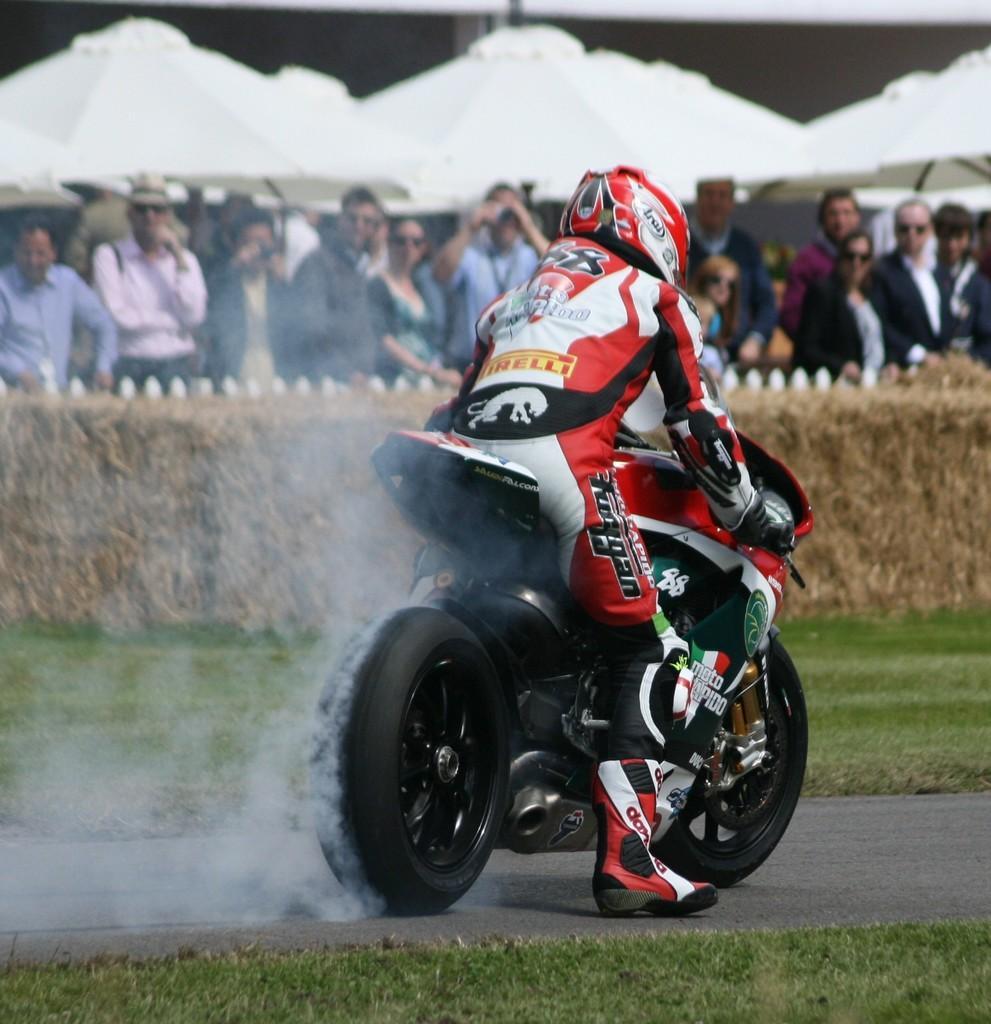How would you summarize this image in a sentence or two? In this picture we can see a man riding a motorbike wearing a helmet. We can see smoke is released from the bike. This is a grass. This is a road. Here we can see all the crowd standing. These are white coloured umbrellas. 